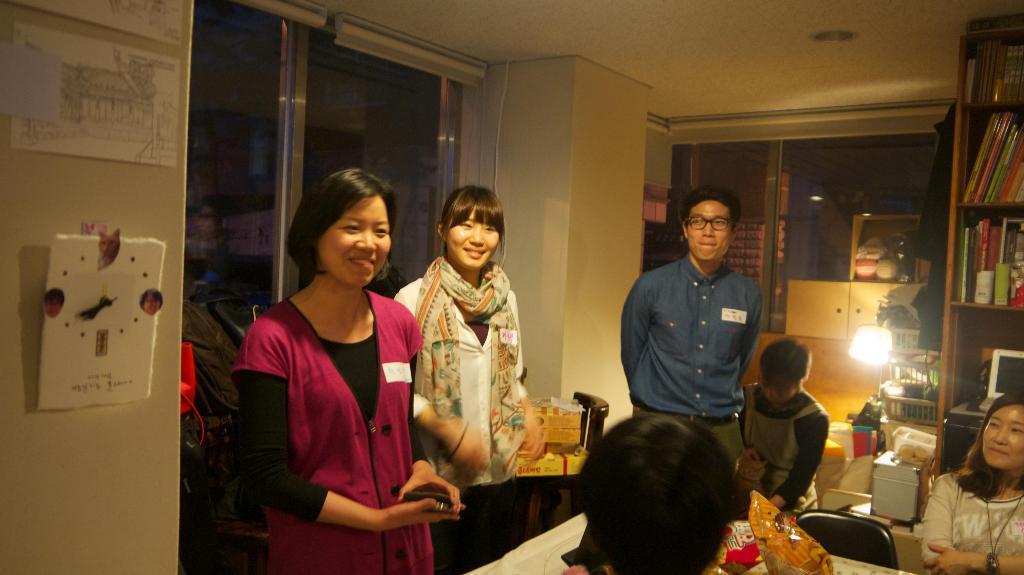In one or two sentences, can you explain what this image depicts? In the center of the image we can see some people are standing. On the right side of the image we can see a rack. In rack we can see the books, laptop. At the bottom of the image we can see a table. On the table we can see some packets. In the background of the image we can see the wall, papers, clock, chairs, lamp, cupboards, windows and some objects. At the top of the image we can see the roof. 